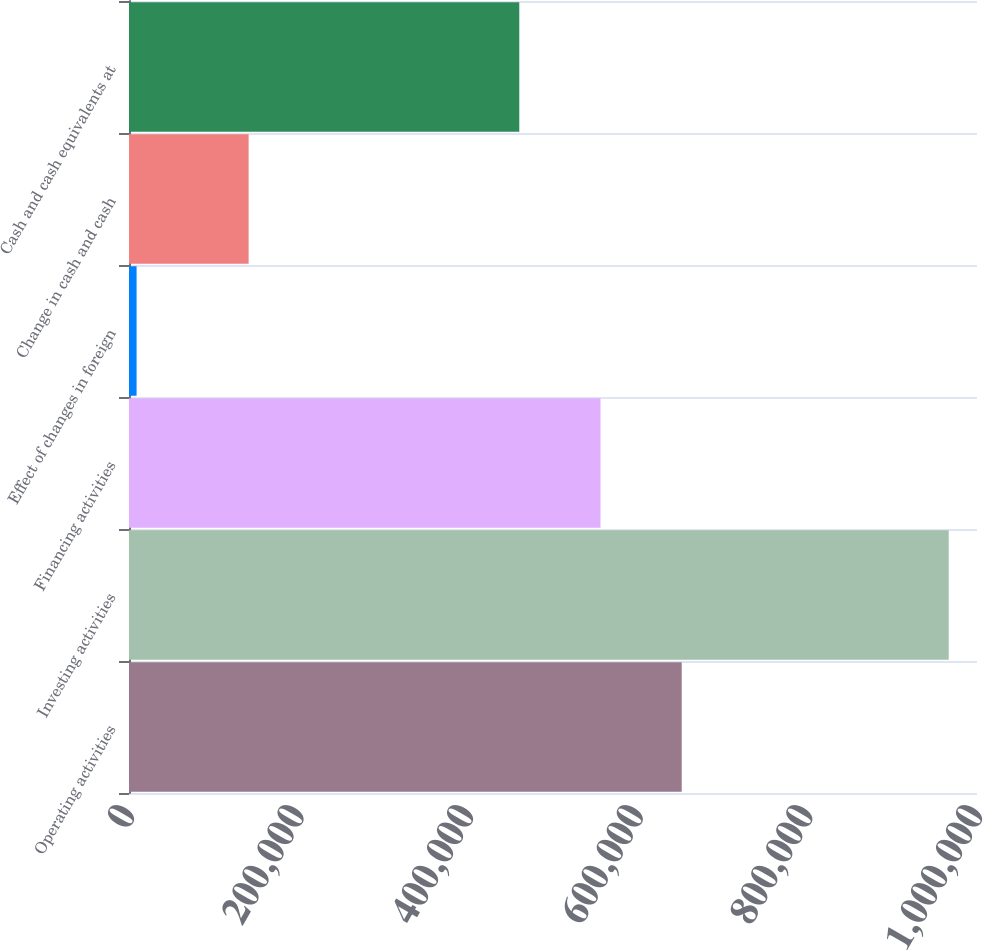Convert chart to OTSL. <chart><loc_0><loc_0><loc_500><loc_500><bar_chart><fcel>Operating activities<fcel>Investing activities<fcel>Financing activities<fcel>Effect of changes in foreign<fcel>Change in cash and cash<fcel>Cash and cash equivalents at<nl><fcel>651784<fcel>966641<fcel>556015<fcel>8944<fcel>141076<fcel>460245<nl></chart> 